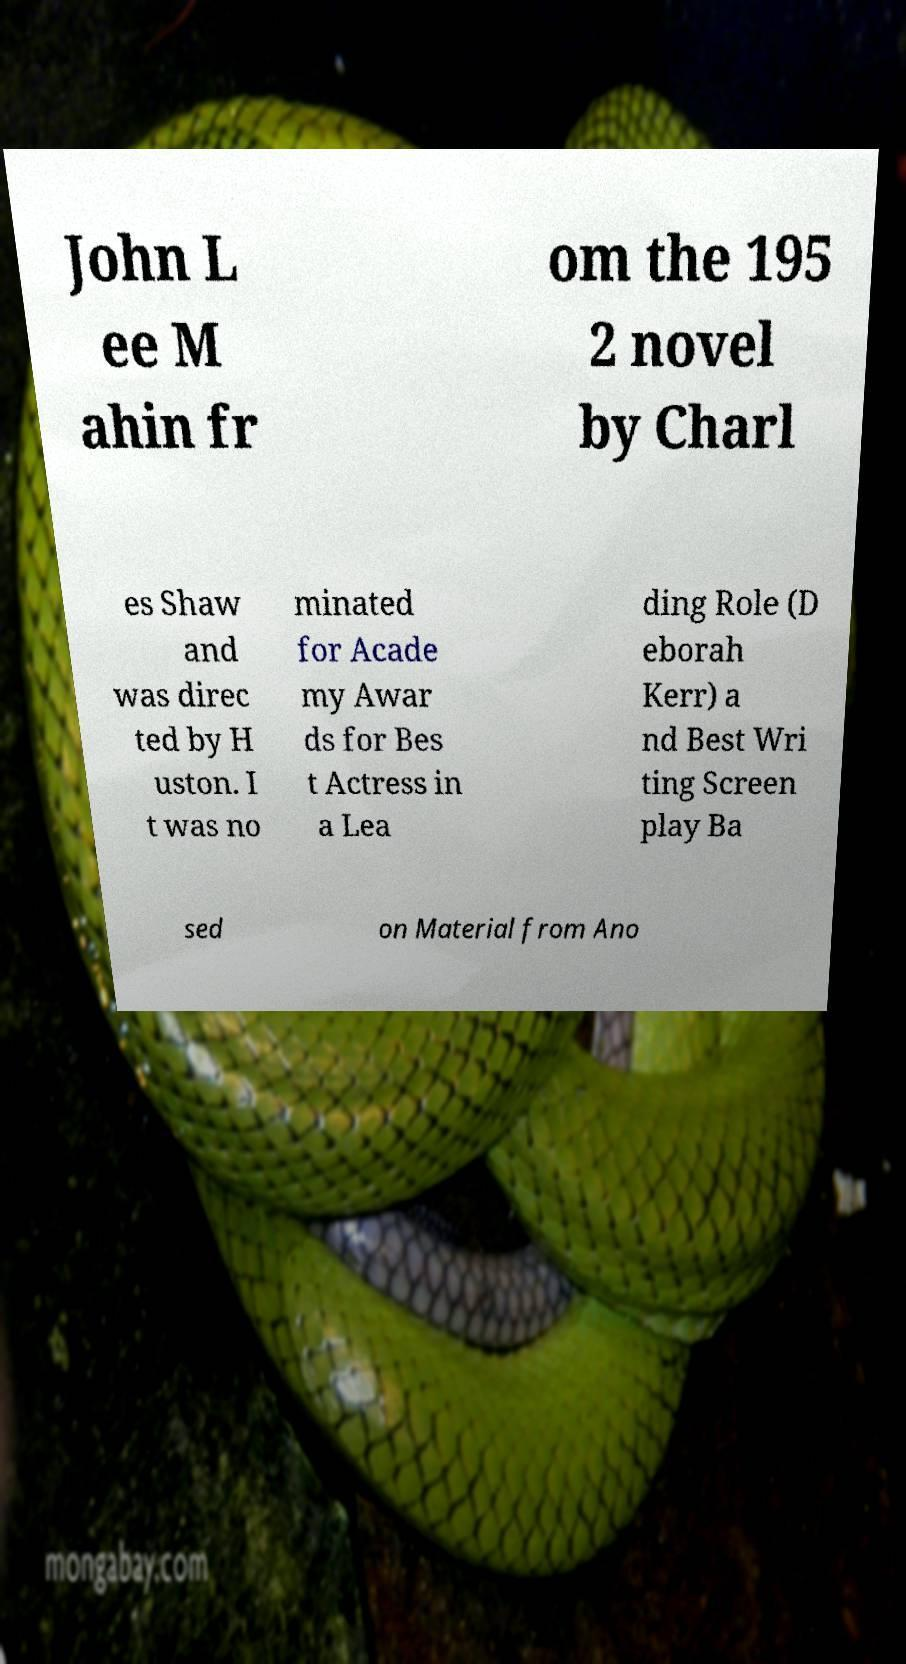For documentation purposes, I need the text within this image transcribed. Could you provide that? John L ee M ahin fr om the 195 2 novel by Charl es Shaw and was direc ted by H uston. I t was no minated for Acade my Awar ds for Bes t Actress in a Lea ding Role (D eborah Kerr) a nd Best Wri ting Screen play Ba sed on Material from Ano 